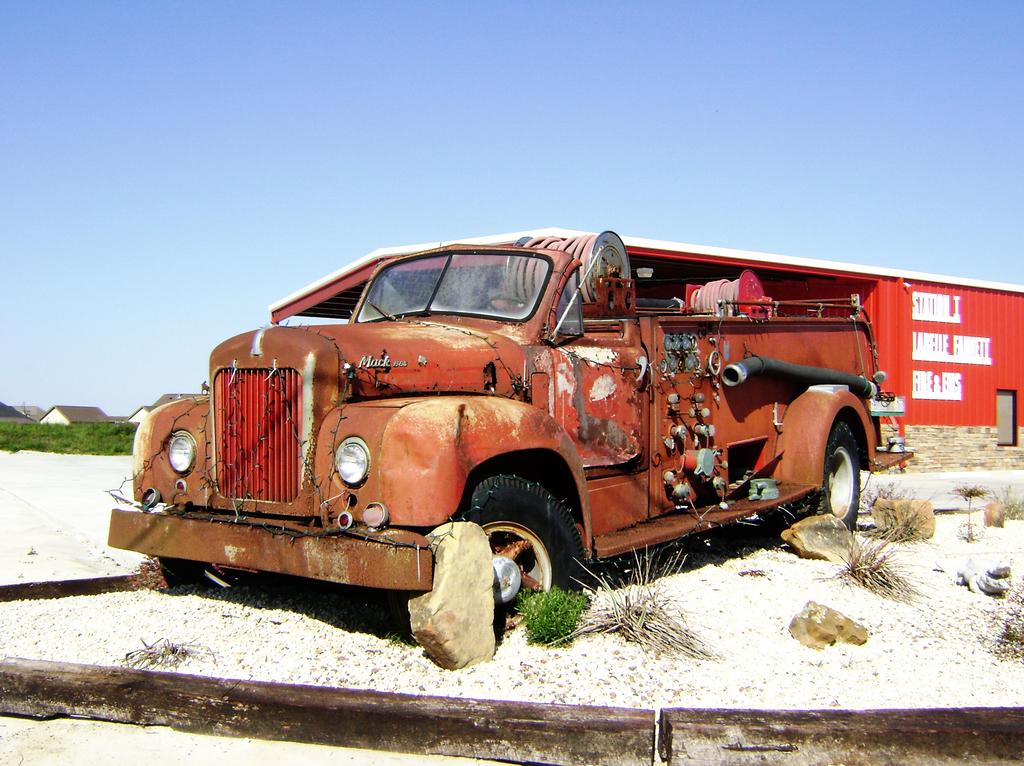What is the main subject in the middle of the image? There is a fire engine in the middle of the image. What can be seen in the background of the image? There is a shed and buildings in the background of the image. What type of vegetation is on the left side of the image? There are trees on the left side of the image. What is visible at the top of the image? The sky is visible at the top of the image. What type of box is being used for war in the image? There is no box or war-related activity present in the image. Which direction is the fire engine facing in the image? The image does not provide information about the direction the fire engine is facing. 